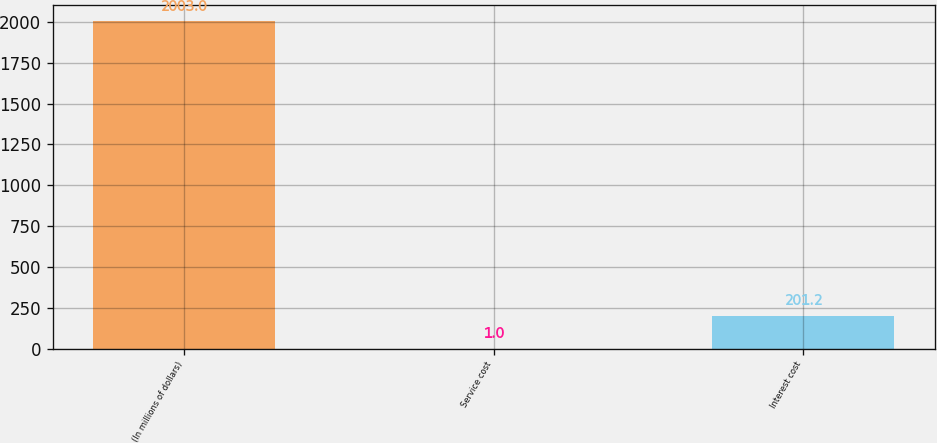Convert chart. <chart><loc_0><loc_0><loc_500><loc_500><bar_chart><fcel>(In millions of dollars)<fcel>Service cost<fcel>Interest cost<nl><fcel>2003<fcel>1<fcel>201.2<nl></chart> 